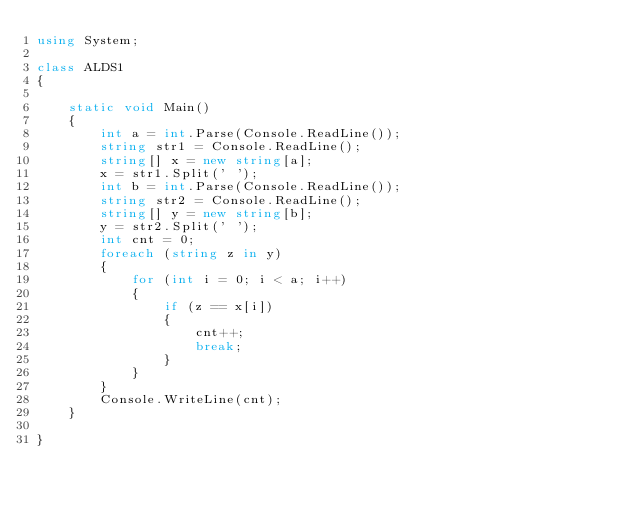Convert code to text. <code><loc_0><loc_0><loc_500><loc_500><_C#_>using System;

class ALDS1
{

    static void Main()
    {
        int a = int.Parse(Console.ReadLine());
        string str1 = Console.ReadLine();
        string[] x = new string[a];
        x = str1.Split(' ');
        int b = int.Parse(Console.ReadLine());
        string str2 = Console.ReadLine();
        string[] y = new string[b];
        y = str2.Split(' ');
        int cnt = 0;
        foreach (string z in y)
        {
            for (int i = 0; i < a; i++)
            {
                if (z == x[i])
                {
                    cnt++;
                    break;
                }
            }
        }
        Console.WriteLine(cnt);
    }

}</code> 